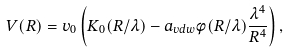Convert formula to latex. <formula><loc_0><loc_0><loc_500><loc_500>V ( R ) = v _ { 0 } \left ( K _ { 0 } ( R / \lambda ) - a _ { v d w } \phi ( R / \lambda ) \frac { \lambda ^ { 4 } } { R ^ { 4 } } \right ) ,</formula> 